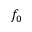<formula> <loc_0><loc_0><loc_500><loc_500>f _ { 0 }</formula> 